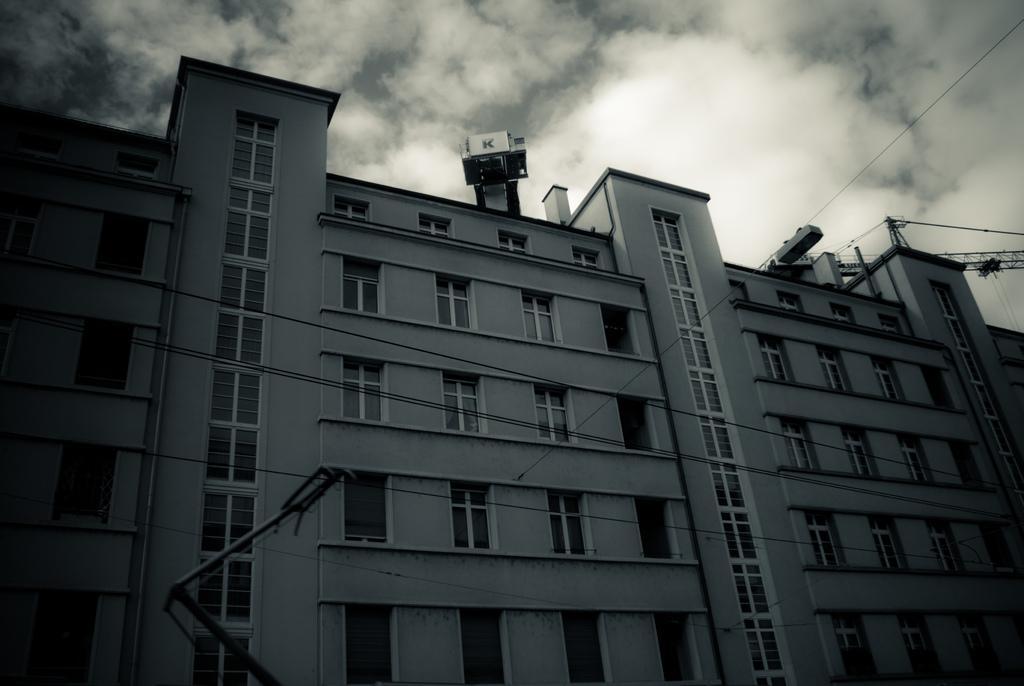How would you summarize this image in a sentence or two? In this image I can see a building, background the sky is in gray and white color. 